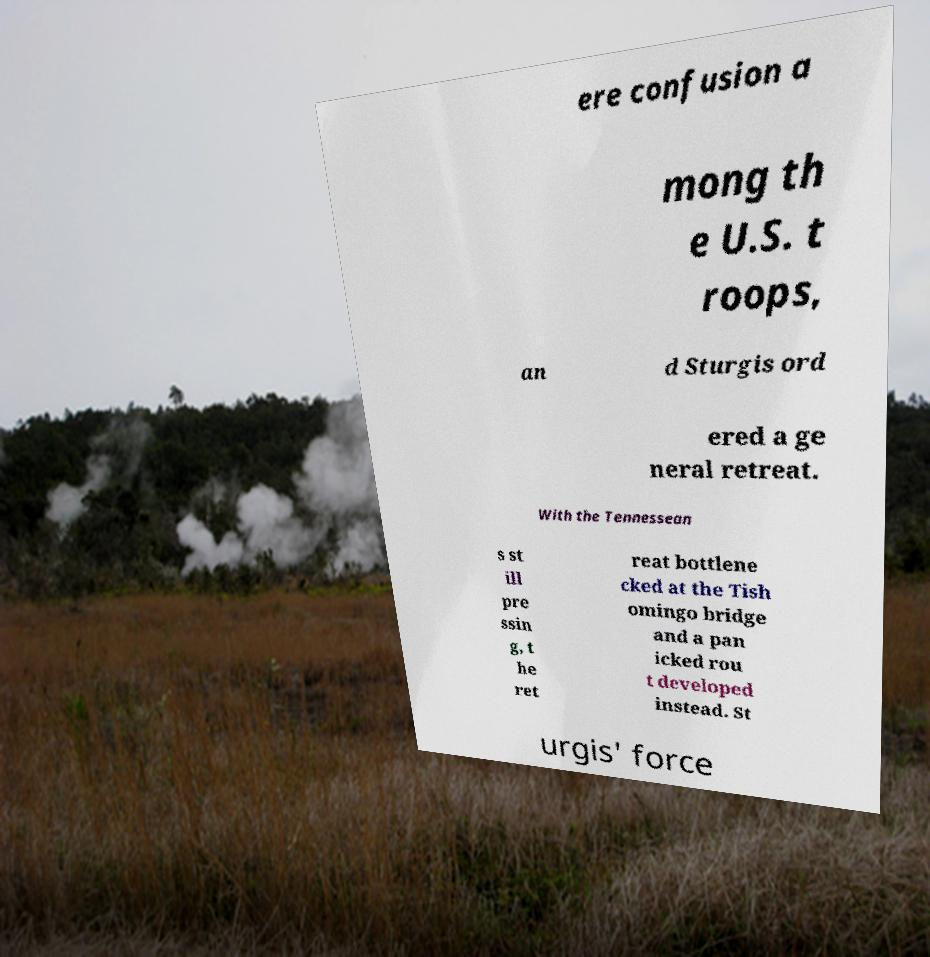Can you read and provide the text displayed in the image?This photo seems to have some interesting text. Can you extract and type it out for me? ere confusion a mong th e U.S. t roops, an d Sturgis ord ered a ge neral retreat. With the Tennessean s st ill pre ssin g, t he ret reat bottlene cked at the Tish omingo bridge and a pan icked rou t developed instead. St urgis' force 